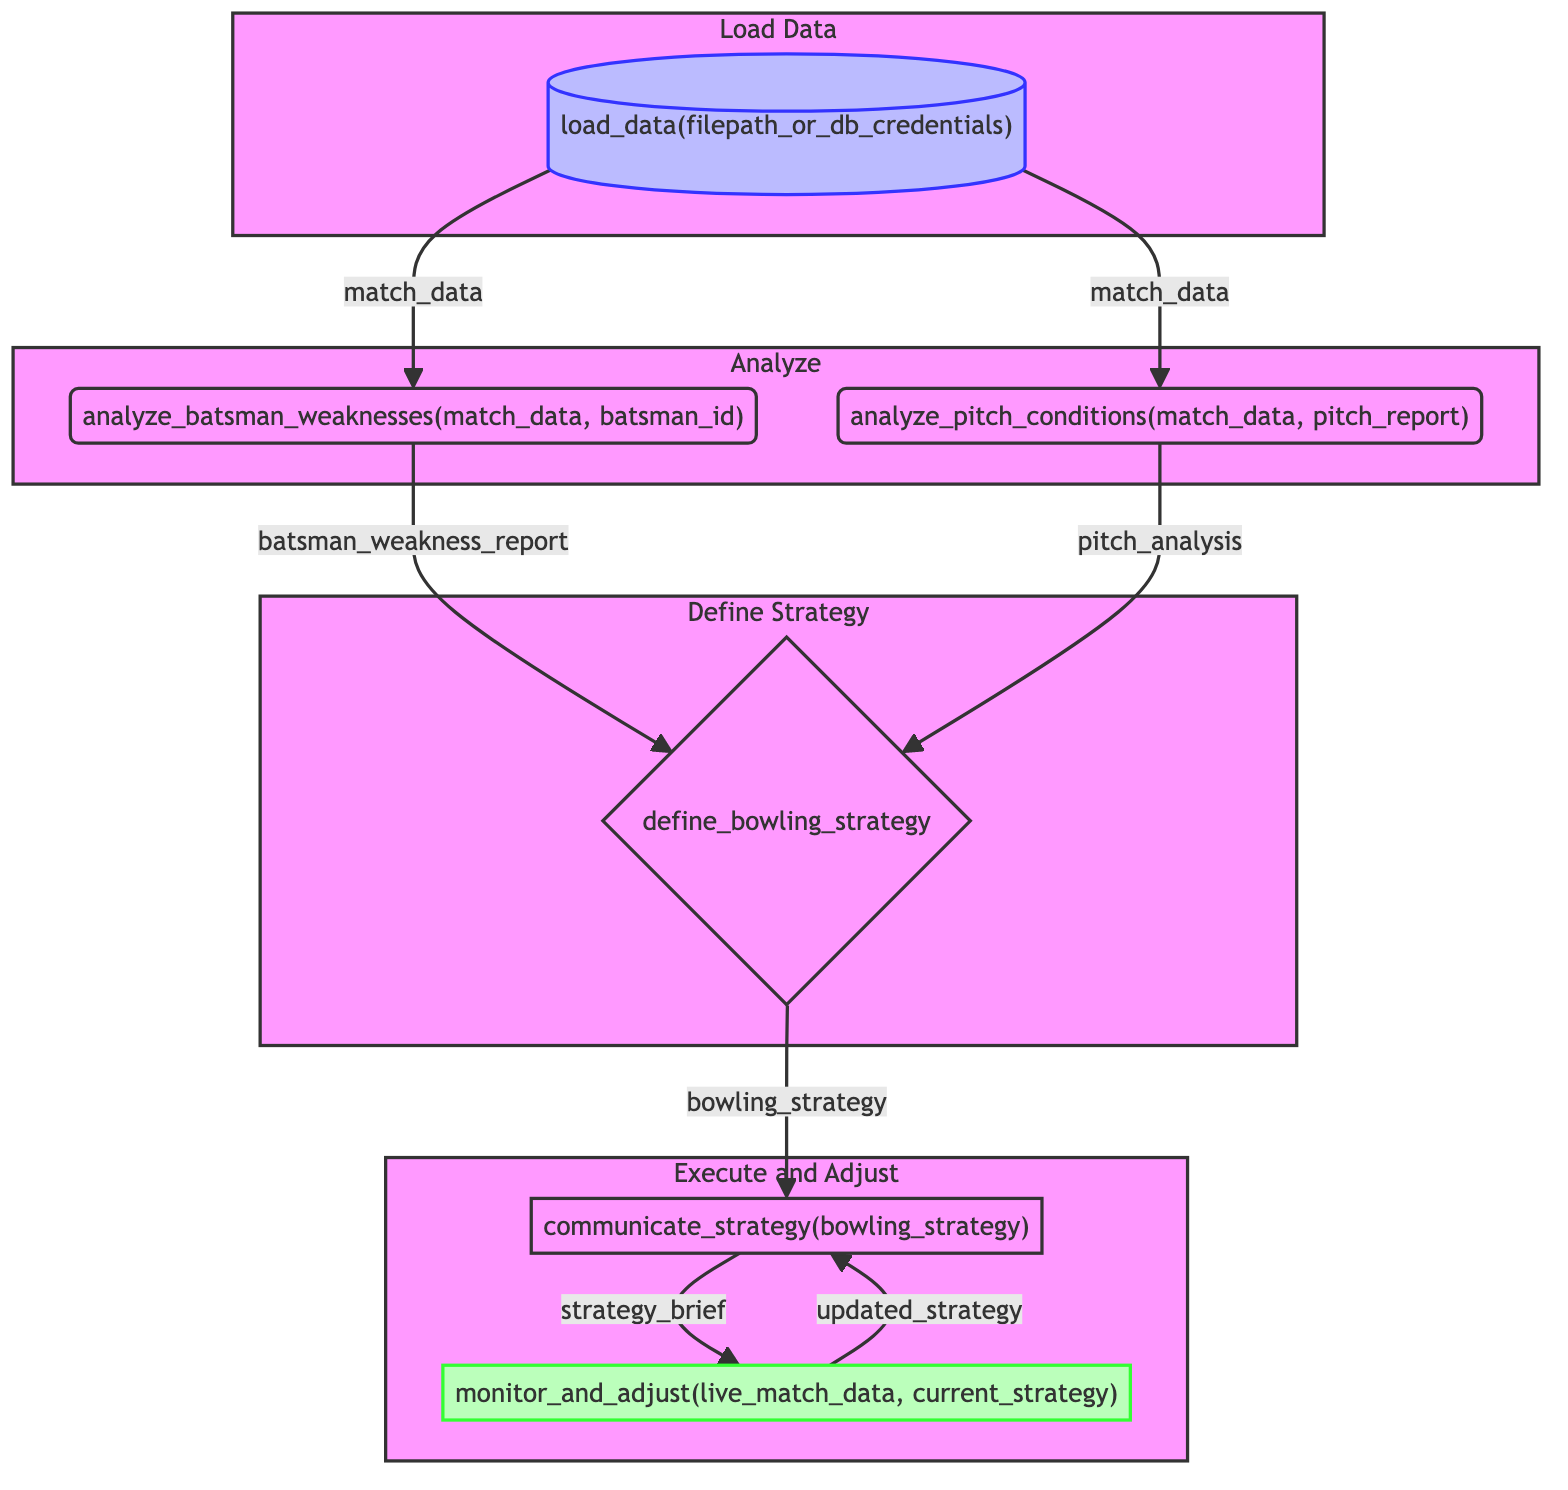what's the first step in the flowchart? The first step in the flowchart is labeled "load_data" and involves loading historical match data.
Answer: load_data how many main steps are there in the flowchart? There are six main steps in the flowchart, including loading data, analyzing, defining strategy, and adjusting.
Answer: six which step immediately follows "analyze_batsman_weaknesses"? The step that immediately follows "analyze_batsman_weaknesses" is "define_bowling_strategy."
Answer: define_bowling_strategy what are the inputs to the step "analyze_pitch_conditions"? The inputs to the step "analyze_pitch_conditions" are "match_data" and "pitch_report."
Answer: match_data, pitch_report what is the output of the "define_bowling_strategy" step? The output of the "define_bowling_strategy" step is "bowling_strategy."
Answer: bowling_strategy how many inputs does the "define_bowling_strategy" step require? The "define_bowling_strategy" step requires two inputs, which are "batsman_weakness_report" and "pitch_analysis."
Answer: two which subgraph contains the "communicate_strategy" step? The "communicate_strategy" step is found in the "Execute and Adjust" subgraph.
Answer: Execute and Adjust what happens after "monitor_and_adjust"? After "monitor_and_adjust," it loops back to "communicate_strategy" for updated advice.
Answer: loops back what are the functionalities of the "load_data" step? The functionalities of the "load_data" step include importing data from CSV or database and filtering data by relevant matches.
Answer: importing data, filtering data what is the main purpose of "monitor_and_adjust"? The main purpose of "monitor_and_adjust" is to track ongoing match data and adjust tactics in real-time.
Answer: track ongoing match data 